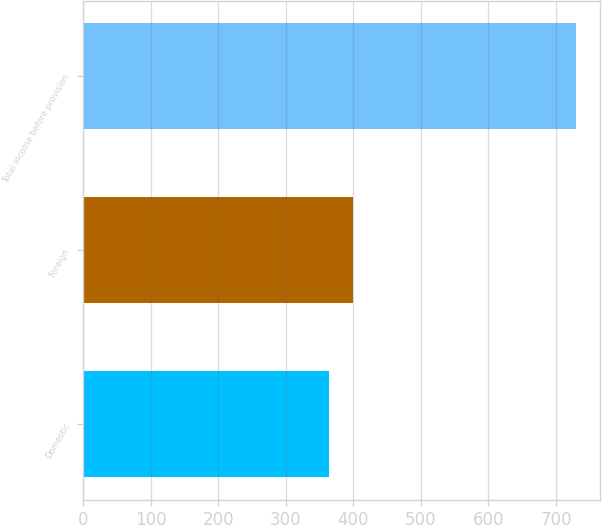Convert chart to OTSL. <chart><loc_0><loc_0><loc_500><loc_500><bar_chart><fcel>Domestic<fcel>Foreign<fcel>Total income before provision<nl><fcel>363.7<fcel>400.22<fcel>728.9<nl></chart> 